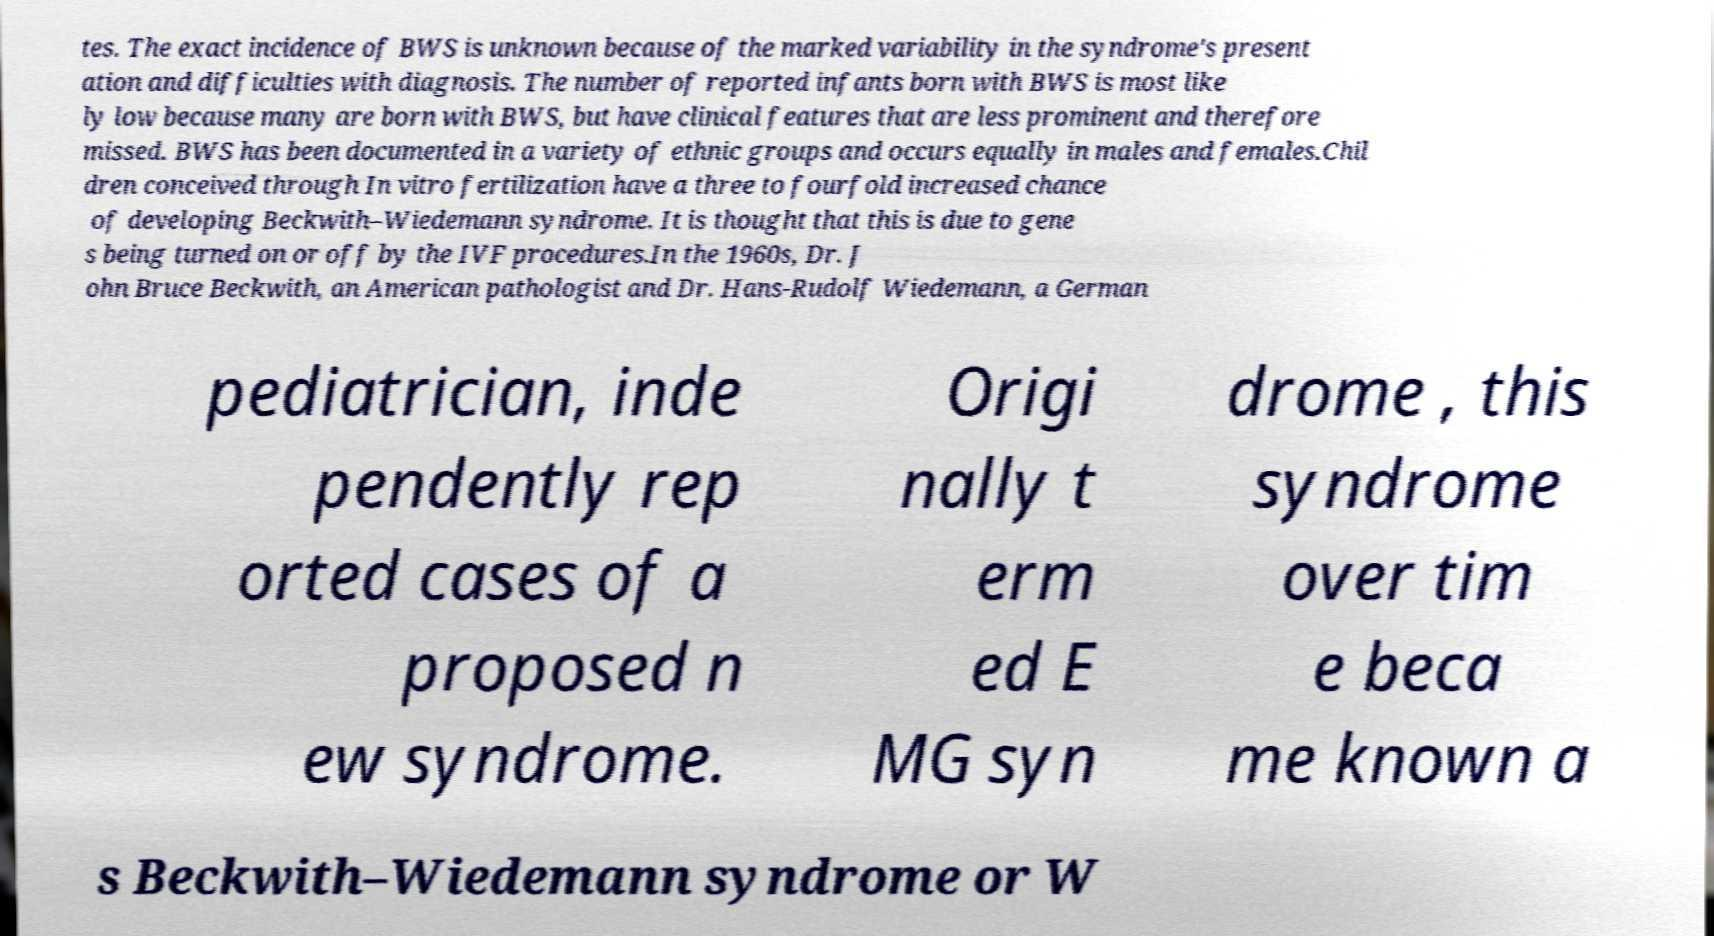Can you accurately transcribe the text from the provided image for me? tes. The exact incidence of BWS is unknown because of the marked variability in the syndrome's present ation and difficulties with diagnosis. The number of reported infants born with BWS is most like ly low because many are born with BWS, but have clinical features that are less prominent and therefore missed. BWS has been documented in a variety of ethnic groups and occurs equally in males and females.Chil dren conceived through In vitro fertilization have a three to fourfold increased chance of developing Beckwith–Wiedemann syndrome. It is thought that this is due to gene s being turned on or off by the IVF procedures.In the 1960s, Dr. J ohn Bruce Beckwith, an American pathologist and Dr. Hans-Rudolf Wiedemann, a German pediatrician, inde pendently rep orted cases of a proposed n ew syndrome. Origi nally t erm ed E MG syn drome , this syndrome over tim e beca me known a s Beckwith–Wiedemann syndrome or W 